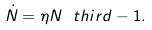Convert formula to latex. <formula><loc_0><loc_0><loc_500><loc_500>\dot { N } = \eta N ^ { \ } t h i r d - 1 .</formula> 